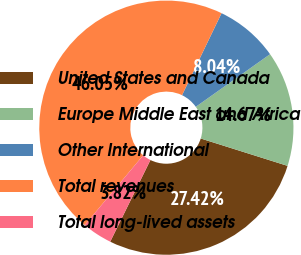<chart> <loc_0><loc_0><loc_500><loc_500><pie_chart><fcel>United States and Canada<fcel>Europe Middle East and Africa<fcel>Other International<fcel>Total revenues<fcel>Total long-lived assets<nl><fcel>27.42%<fcel>14.67%<fcel>8.04%<fcel>46.05%<fcel>3.82%<nl></chart> 